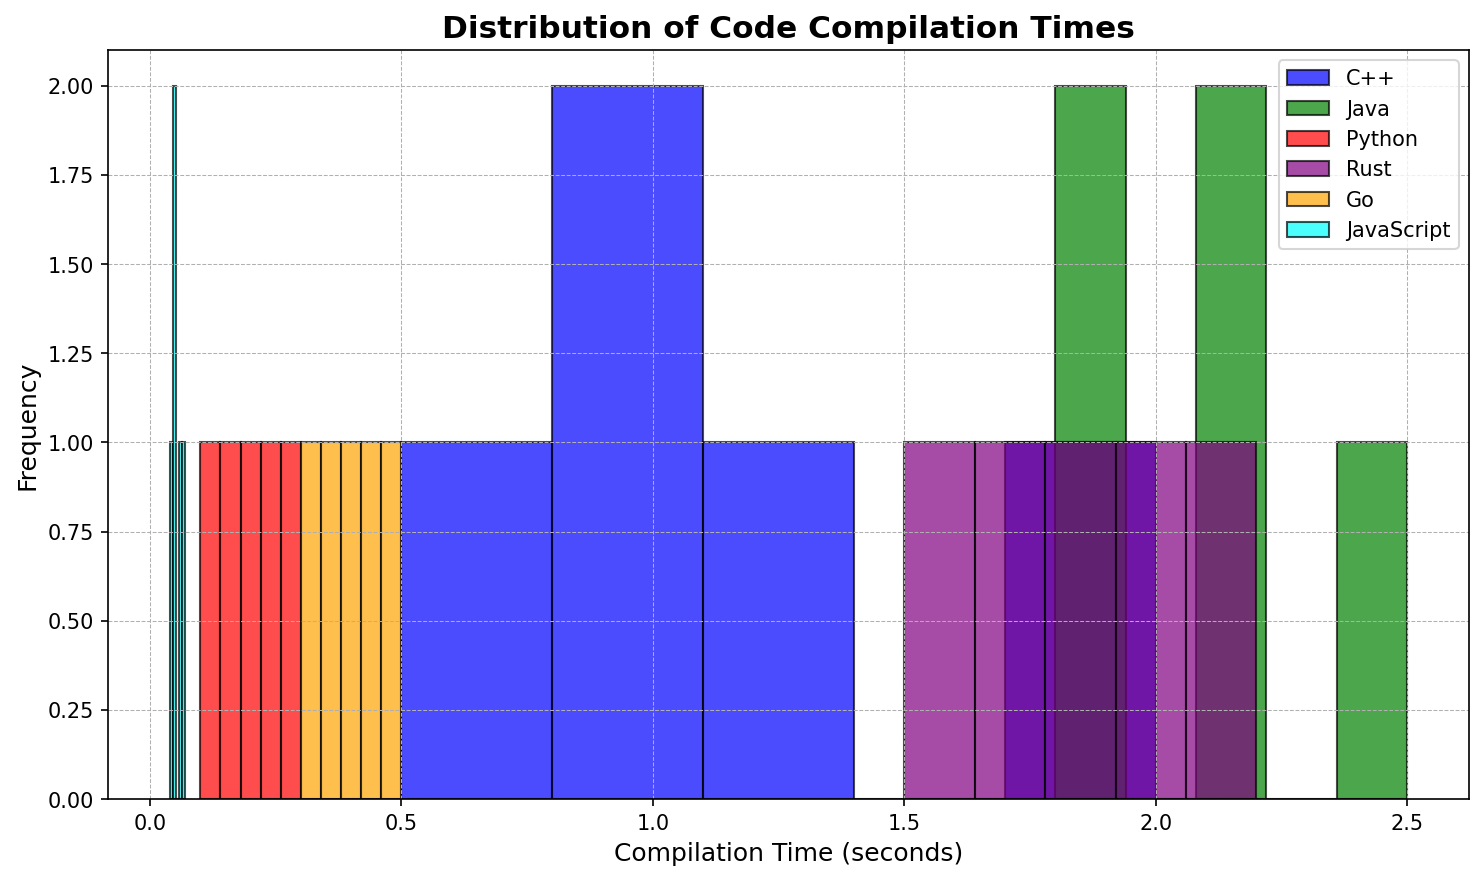Which language has the highest compilation time frequency in the 0.1 to 0.5 seconds range? Observing the histogram, it is evident that the language with the largest frequency within the 0.1 to 0.5 seconds range has the most noticeable bar height. In this case, Python has the highest frequency in this interval.
Answer: Python Which language shows the most variation in compilation times? To determine the variation, we look for the language that has bars spread out over a wider range of the x-axis. In this case, C++ shows bars across a larger range (from 0.5 to 2.0 seconds) compared to other languages.
Answer: C++ Between Java and C++, which language has the most consistent compilation times? Consistency can be observed by looking at the clustering of bars. Java’s bars are clustered closely together between 1.8 to 2.5 seconds, whereas C++'s bars are more spread out from 0.5 to 2.0 seconds, indicating that Java has more consistent compilation times.
Answer: Java What is the median compilation time for Go? The median is the middle value of a sorted list. The compilation times for Go are: 0.3, 0.35, 0.4, 0.45, 0.5. The middle value (median) is 0.4.
Answer: 0.4 seconds Which language has the least average compilation time and what is it? To find the average, sum up the compilation times of each language and divide by the number of compilations. For JavaScript: (0.05+0.07+0.04+0.06+0.05)/5 = 0.054 seconds. The least average compilation time is for JavaScript.
Answer: JavaScript, 0.054 seconds Consider the interval of 1 to 2 seconds. Which two languages fall into this range and how do they compare? The languages with bars in the interval 1 to 2 seconds are C++ and Java. Comparing their histogram bars, C++ has one bar while Java has four, indicating that Java has more compilation times within this range.
Answer: C++ and Java; Java has more Which language's maximum compilation time is observed and what is it? Observing the rightmost bar for each language gives us the maximum compilation time. Rust has the maximum compilation time with a value of 2.2 seconds.
Answer: Rust, 2.2 seconds How many languages have their highest frequency compilation time below 1 second? By observing the highest bars in the histogram for each language, the languages with bars only appearing below 1 second are Python, Go, and JavaScript.
Answer: Three languages Which language has the shortest compilation time, and what is it? Observing the histogram, the shortest compilation time is the leftmost bar in the graph. JavaScript has the shortest compilation time with a value of 0.04 seconds.
Answer: JavaScript, 0.04 seconds 